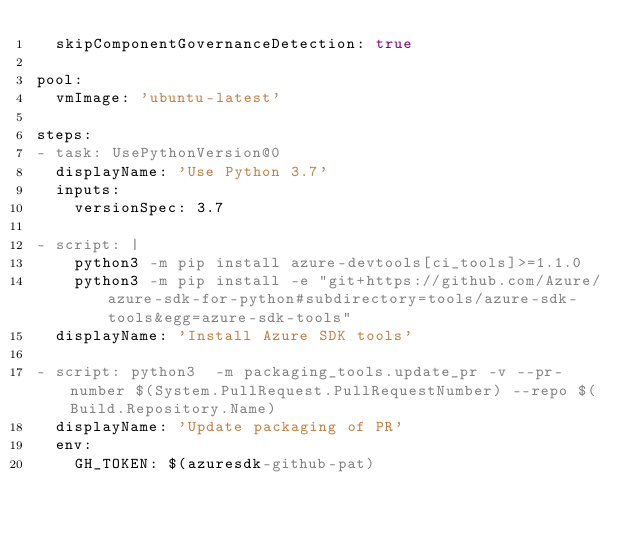Convert code to text. <code><loc_0><loc_0><loc_500><loc_500><_YAML_>  skipComponentGovernanceDetection: true

pool:
  vmImage: 'ubuntu-latest'

steps:
- task: UsePythonVersion@0
  displayName: 'Use Python 3.7'
  inputs:
    versionSpec: 3.7

- script: |
    python3 -m pip install azure-devtools[ci_tools]>=1.1.0
    python3 -m pip install -e "git+https://github.com/Azure/azure-sdk-for-python#subdirectory=tools/azure-sdk-tools&egg=azure-sdk-tools"
  displayName: 'Install Azure SDK tools'

- script: python3  -m packaging_tools.update_pr -v --pr-number $(System.PullRequest.PullRequestNumber) --repo $(Build.Repository.Name)
  displayName: 'Update packaging of PR'
  env:
    GH_TOKEN: $(azuresdk-github-pat)
</code> 